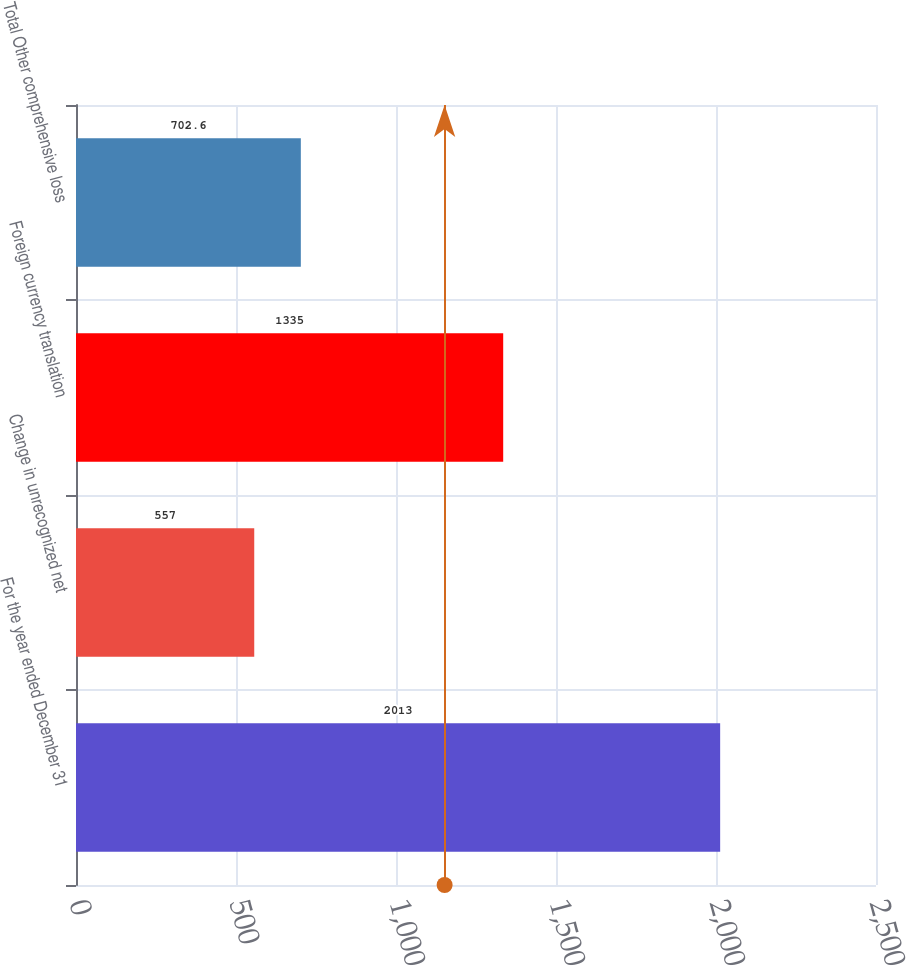Convert chart. <chart><loc_0><loc_0><loc_500><loc_500><bar_chart><fcel>For the year ended December 31<fcel>Change in unrecognized net<fcel>Foreign currency translation<fcel>Total Other comprehensive loss<nl><fcel>2013<fcel>557<fcel>1335<fcel>702.6<nl></chart> 